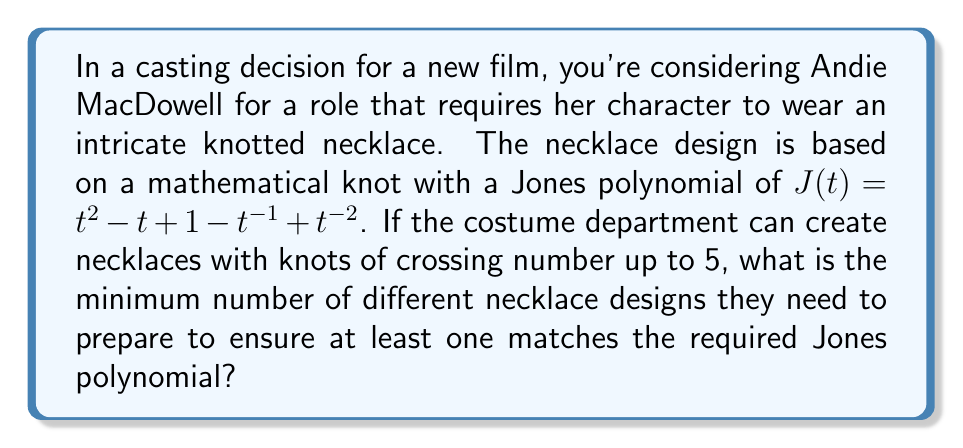Give your solution to this math problem. To solve this problem, we need to follow these steps:

1) Recall that the Jones polynomial is a knot invariant, meaning it remains unchanged under continuous deformations of the knot.

2) The given Jones polynomial is $J(t) = t^2 - t + 1 - t^{-1} + t^{-2}$.

3) The degree of this polynomial is 4 (from $t^2$ to $t^{-2}$), which gives us a lower bound on the crossing number of the knot.

4) The crossing number of a knot is the minimum number of crossings in any diagram of the knot. It's also related to the complexity of the knot.

5) For knots with crossing number up to 5, we have:
   - 1 knot with crossing number 0 (the unknot)
   - 0 knots with crossing number 1 or 2 (impossible)
   - 1 knot with crossing number 3 (the trefoil knot)
   - 1 knot with crossing number 4 (the figure-eight knot)
   - 2 knots with crossing number 5

6) In total, there are 1 + 1 + 1 + 2 = 5 distinct knots with crossing number up to 5.

7) Each of these knots will have a unique Jones polynomial.

8) Therefore, to ensure at least one necklace matches the required Jones polynomial, the costume department needs to prepare all 5 possible designs.
Answer: 5 necklace designs 